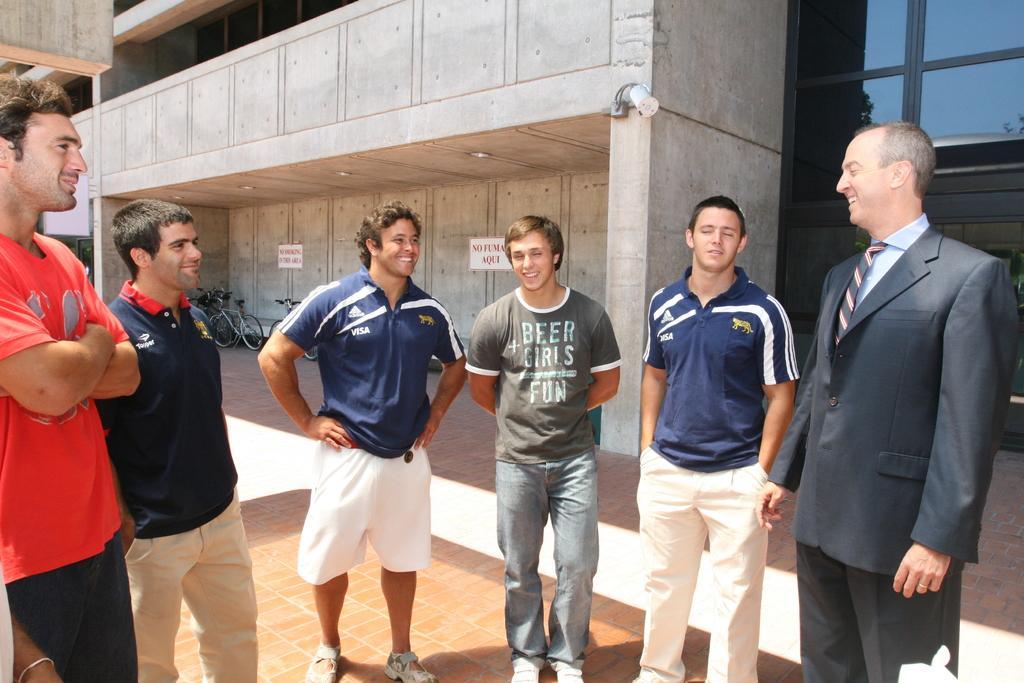Describe this image in one or two sentences. In this picture I can see a group of people are standing, in the background there are bicycles and a building, on the right side I can see the glass wall. 